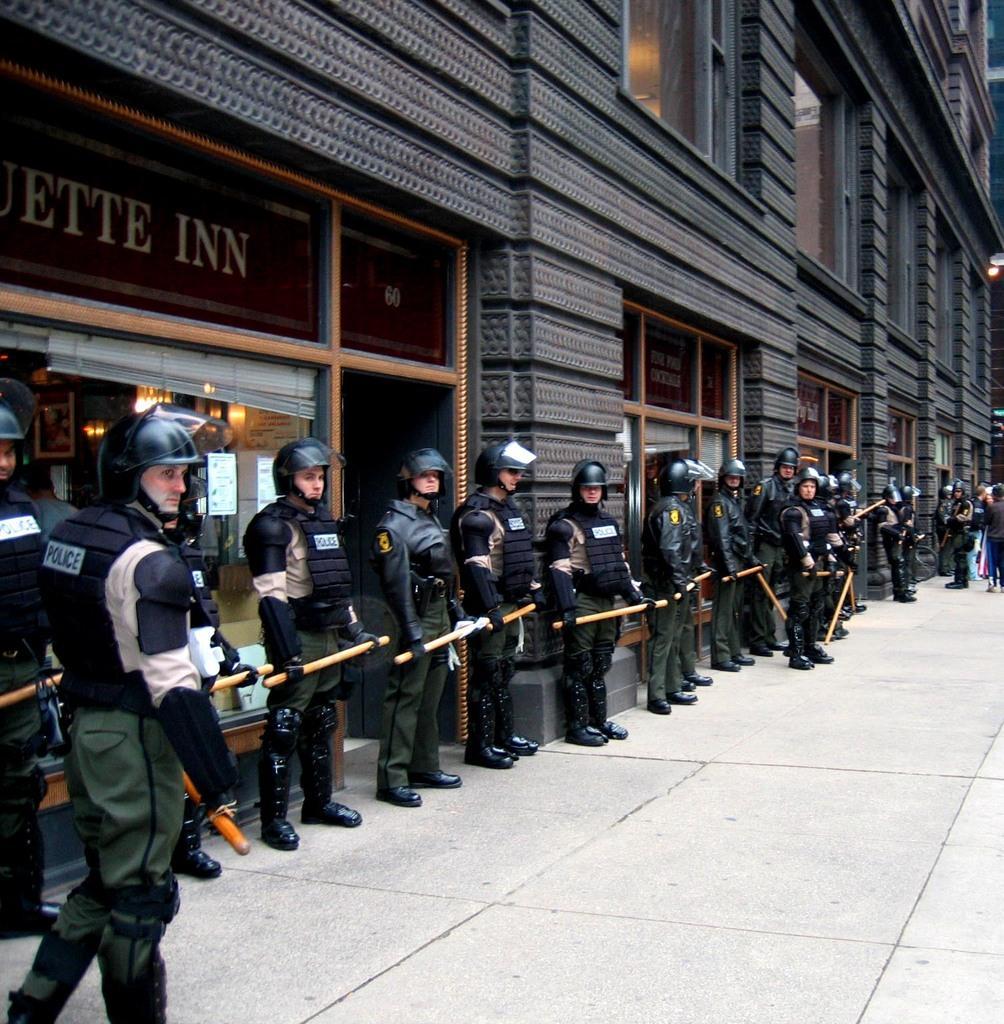Can you describe this image briefly? In this picture we can see a group of people standing on the ground, they are holding sticks, here we can see a building, posters, lights. 